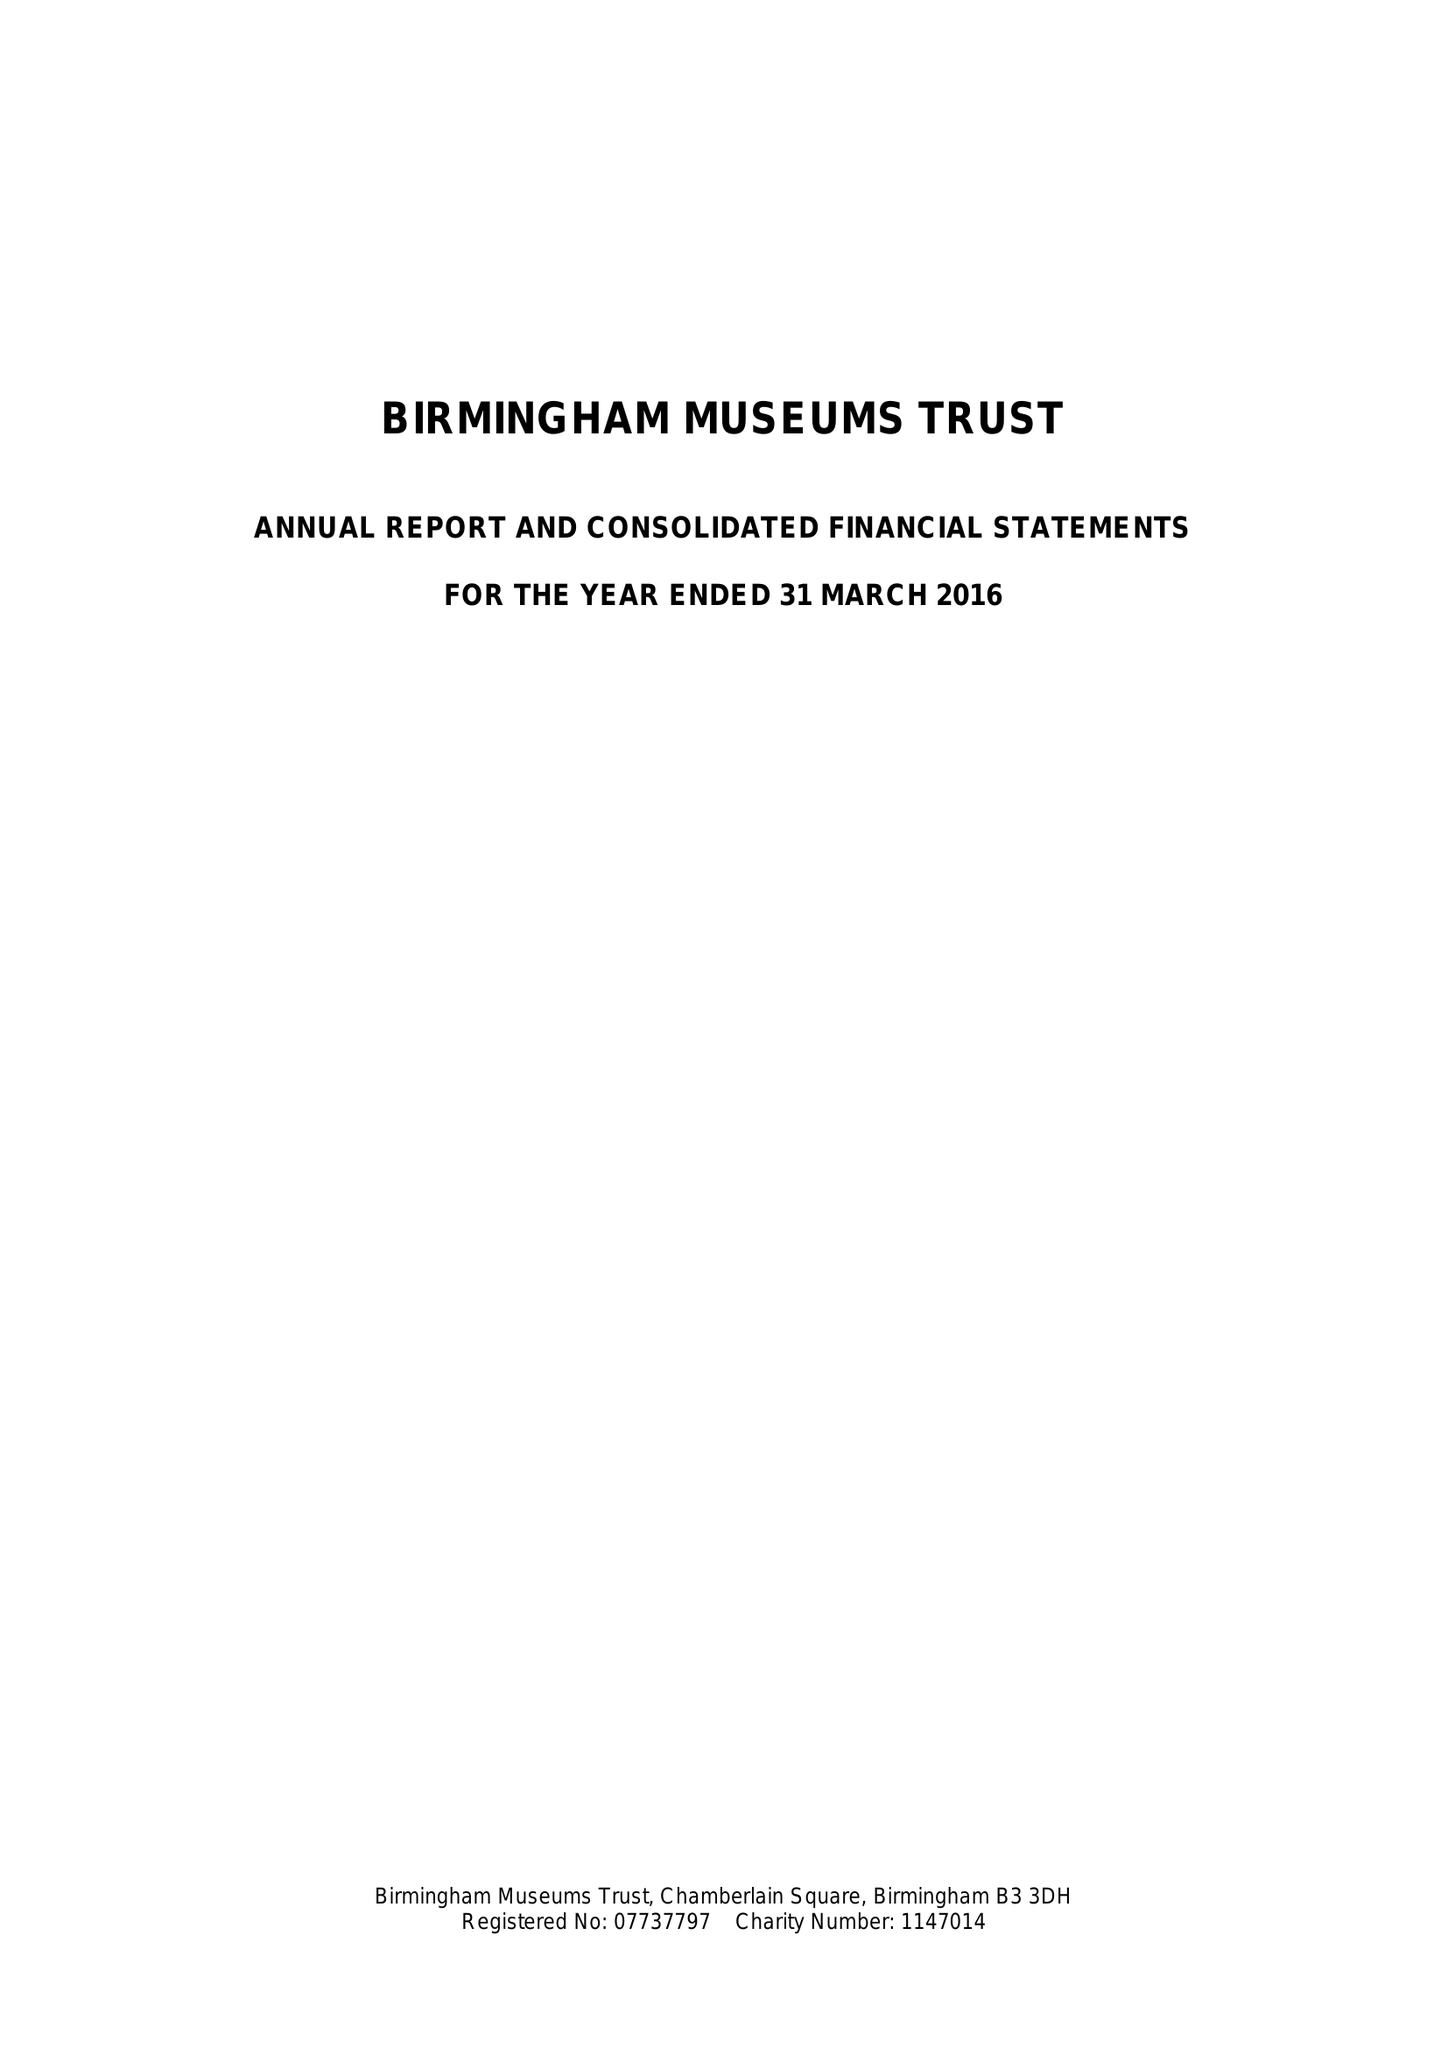What is the value for the charity_number?
Answer the question using a single word or phrase. 1147014 